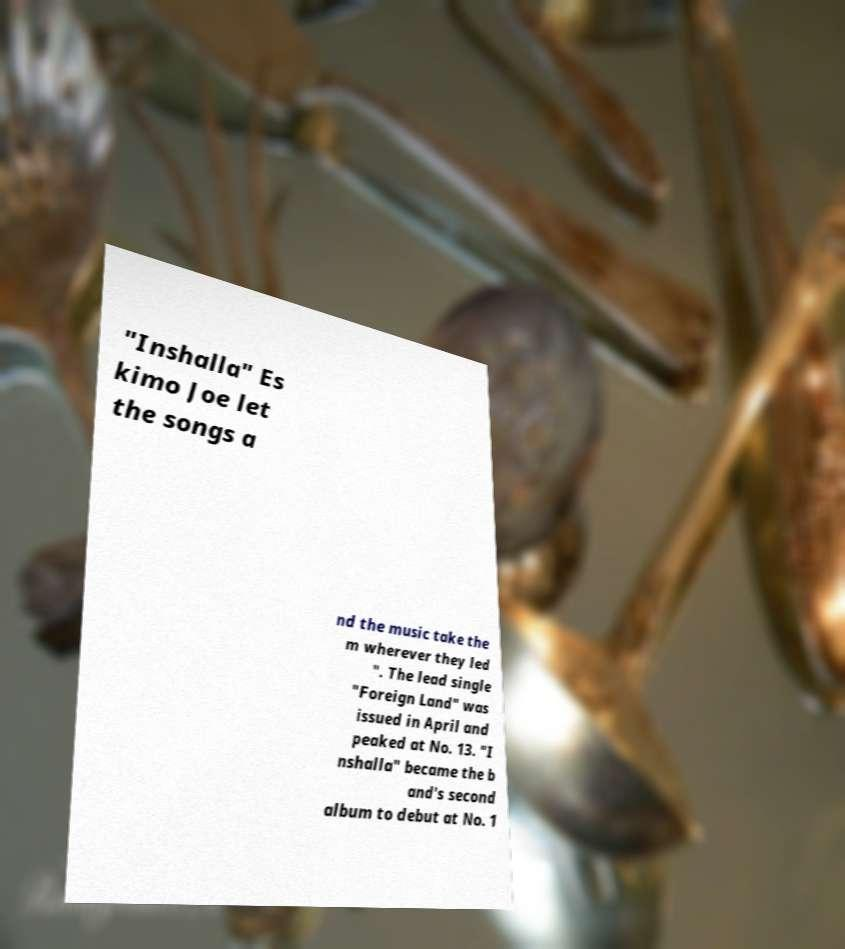Could you assist in decoding the text presented in this image and type it out clearly? "Inshalla" Es kimo Joe let the songs a nd the music take the m wherever they led ". The lead single "Foreign Land" was issued in April and peaked at No. 13. "I nshalla" became the b and's second album to debut at No. 1 